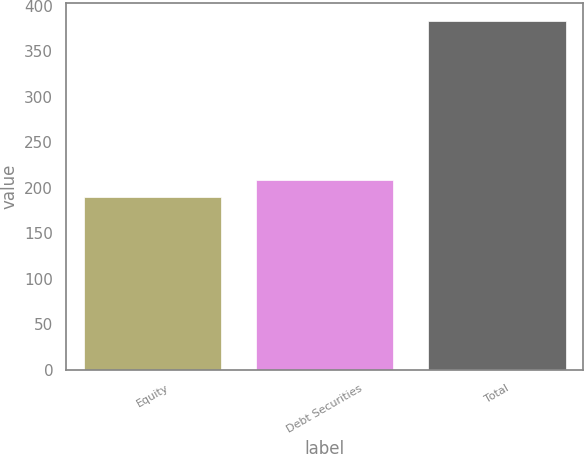Convert chart. <chart><loc_0><loc_0><loc_500><loc_500><bar_chart><fcel>Equity<fcel>Debt Securities<fcel>Total<nl><fcel>189.5<fcel>208.93<fcel>383.8<nl></chart> 